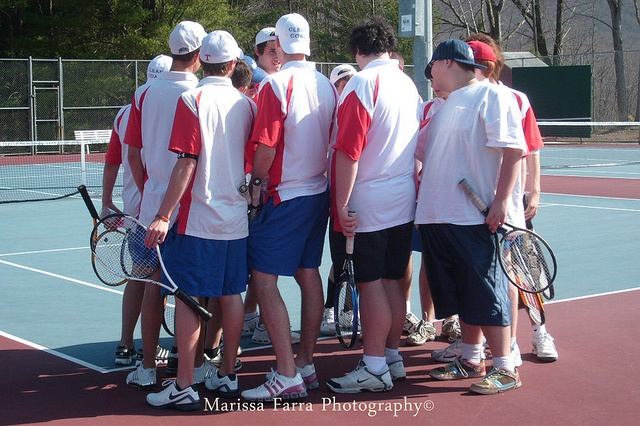Describe the objects in this image and their specific colors. I can see people in black, darkgray, and white tones, people in black, white, darkgray, and gray tones, people in black, navy, purple, and white tones, people in black, navy, darkgray, purple, and white tones, and people in black, gray, and maroon tones in this image. 